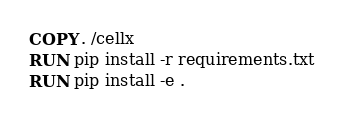Convert code to text. <code><loc_0><loc_0><loc_500><loc_500><_Dockerfile_>COPY . /cellx
RUN pip install -r requirements.txt
RUN pip install -e .
</code> 